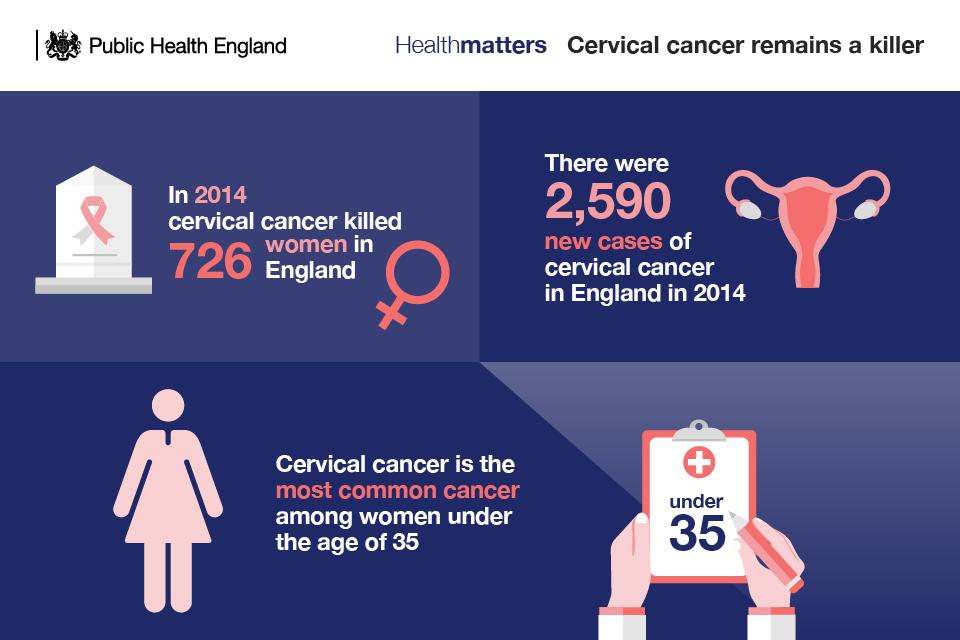Outline some significant characteristics in this image. The number of new cases of cervical cancer was higher than the number of women who were killed because of it in 2014. The number of times the year 2014 appeared in the infographic is not known. In the second graphic, the color used as the background color is either blue, black, or white. The infographic contains four instances of the word "cervical cancer. The number "35" appeared a total of two times in the infographic. 